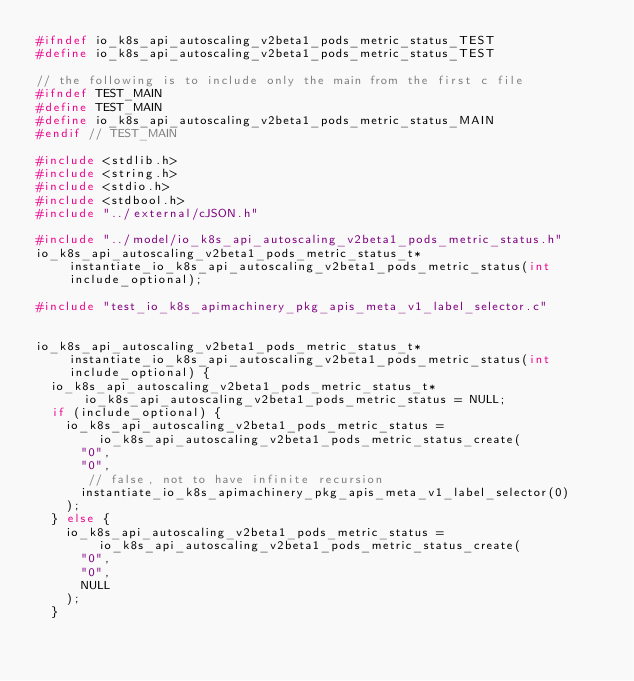<code> <loc_0><loc_0><loc_500><loc_500><_C_>#ifndef io_k8s_api_autoscaling_v2beta1_pods_metric_status_TEST
#define io_k8s_api_autoscaling_v2beta1_pods_metric_status_TEST

// the following is to include only the main from the first c file
#ifndef TEST_MAIN
#define TEST_MAIN
#define io_k8s_api_autoscaling_v2beta1_pods_metric_status_MAIN
#endif // TEST_MAIN

#include <stdlib.h>
#include <string.h>
#include <stdio.h>
#include <stdbool.h>
#include "../external/cJSON.h"

#include "../model/io_k8s_api_autoscaling_v2beta1_pods_metric_status.h"
io_k8s_api_autoscaling_v2beta1_pods_metric_status_t* instantiate_io_k8s_api_autoscaling_v2beta1_pods_metric_status(int include_optional);

#include "test_io_k8s_apimachinery_pkg_apis_meta_v1_label_selector.c"


io_k8s_api_autoscaling_v2beta1_pods_metric_status_t* instantiate_io_k8s_api_autoscaling_v2beta1_pods_metric_status(int include_optional) {
  io_k8s_api_autoscaling_v2beta1_pods_metric_status_t* io_k8s_api_autoscaling_v2beta1_pods_metric_status = NULL;
  if (include_optional) {
    io_k8s_api_autoscaling_v2beta1_pods_metric_status = io_k8s_api_autoscaling_v2beta1_pods_metric_status_create(
      "0",
      "0",
       // false, not to have infinite recursion
      instantiate_io_k8s_apimachinery_pkg_apis_meta_v1_label_selector(0)
    );
  } else {
    io_k8s_api_autoscaling_v2beta1_pods_metric_status = io_k8s_api_autoscaling_v2beta1_pods_metric_status_create(
      "0",
      "0",
      NULL
    );
  }
</code> 